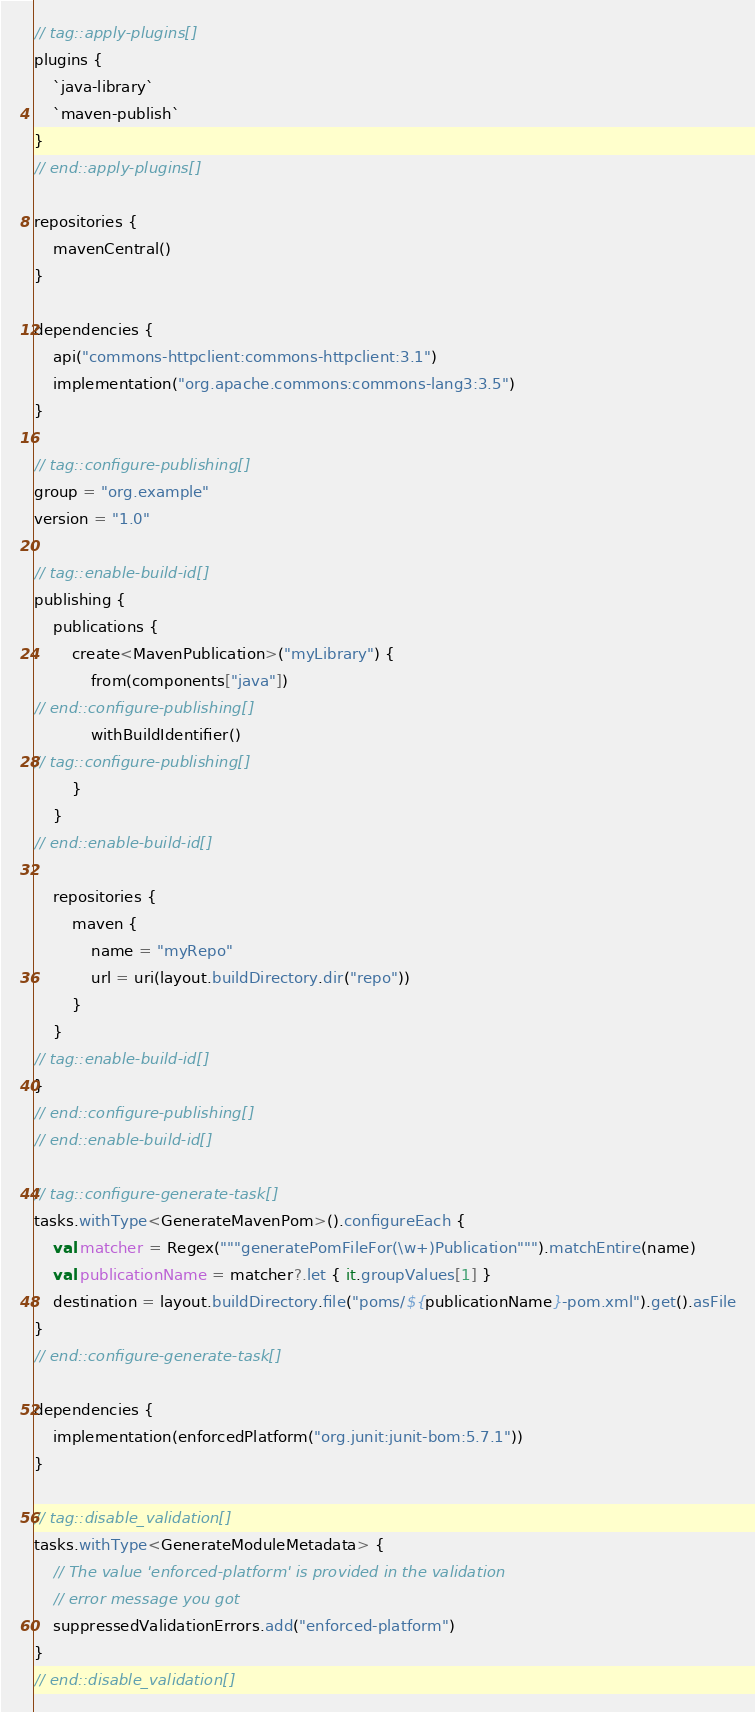<code> <loc_0><loc_0><loc_500><loc_500><_Kotlin_>// tag::apply-plugins[]
plugins {
    `java-library`
    `maven-publish`
}
// end::apply-plugins[]

repositories {
    mavenCentral()
}

dependencies {
    api("commons-httpclient:commons-httpclient:3.1")
    implementation("org.apache.commons:commons-lang3:3.5")
}

// tag::configure-publishing[]
group = "org.example"
version = "1.0"

// tag::enable-build-id[]
publishing {
    publications {
        create<MavenPublication>("myLibrary") {
            from(components["java"])
// end::configure-publishing[]
            withBuildIdentifier()
// tag::configure-publishing[]
        }
    }
// end::enable-build-id[]

    repositories {
        maven {
            name = "myRepo"
            url = uri(layout.buildDirectory.dir("repo"))
        }
    }
// tag::enable-build-id[]
}
// end::configure-publishing[]
// end::enable-build-id[]

// tag::configure-generate-task[]
tasks.withType<GenerateMavenPom>().configureEach {
    val matcher = Regex("""generatePomFileFor(\w+)Publication""").matchEntire(name)
    val publicationName = matcher?.let { it.groupValues[1] }
    destination = layout.buildDirectory.file("poms/${publicationName}-pom.xml").get().asFile
}
// end::configure-generate-task[]

dependencies {
    implementation(enforcedPlatform("org.junit:junit-bom:5.7.1"))
}

// tag::disable_validation[]
tasks.withType<GenerateModuleMetadata> {
    // The value 'enforced-platform' is provided in the validation
    // error message you got
    suppressedValidationErrors.add("enforced-platform")
}
// end::disable_validation[]
</code> 